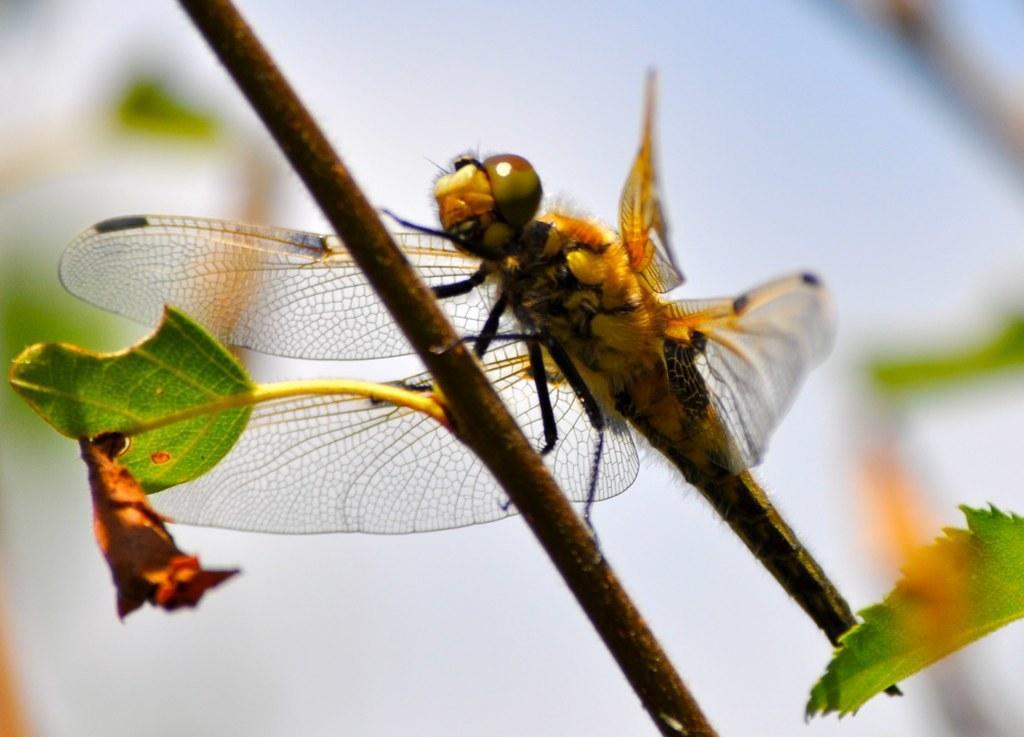In one or two sentences, can you explain what this image depicts? In this image we can see an insect on the plant stem and there are few leaves and in the background the image is blurred. 